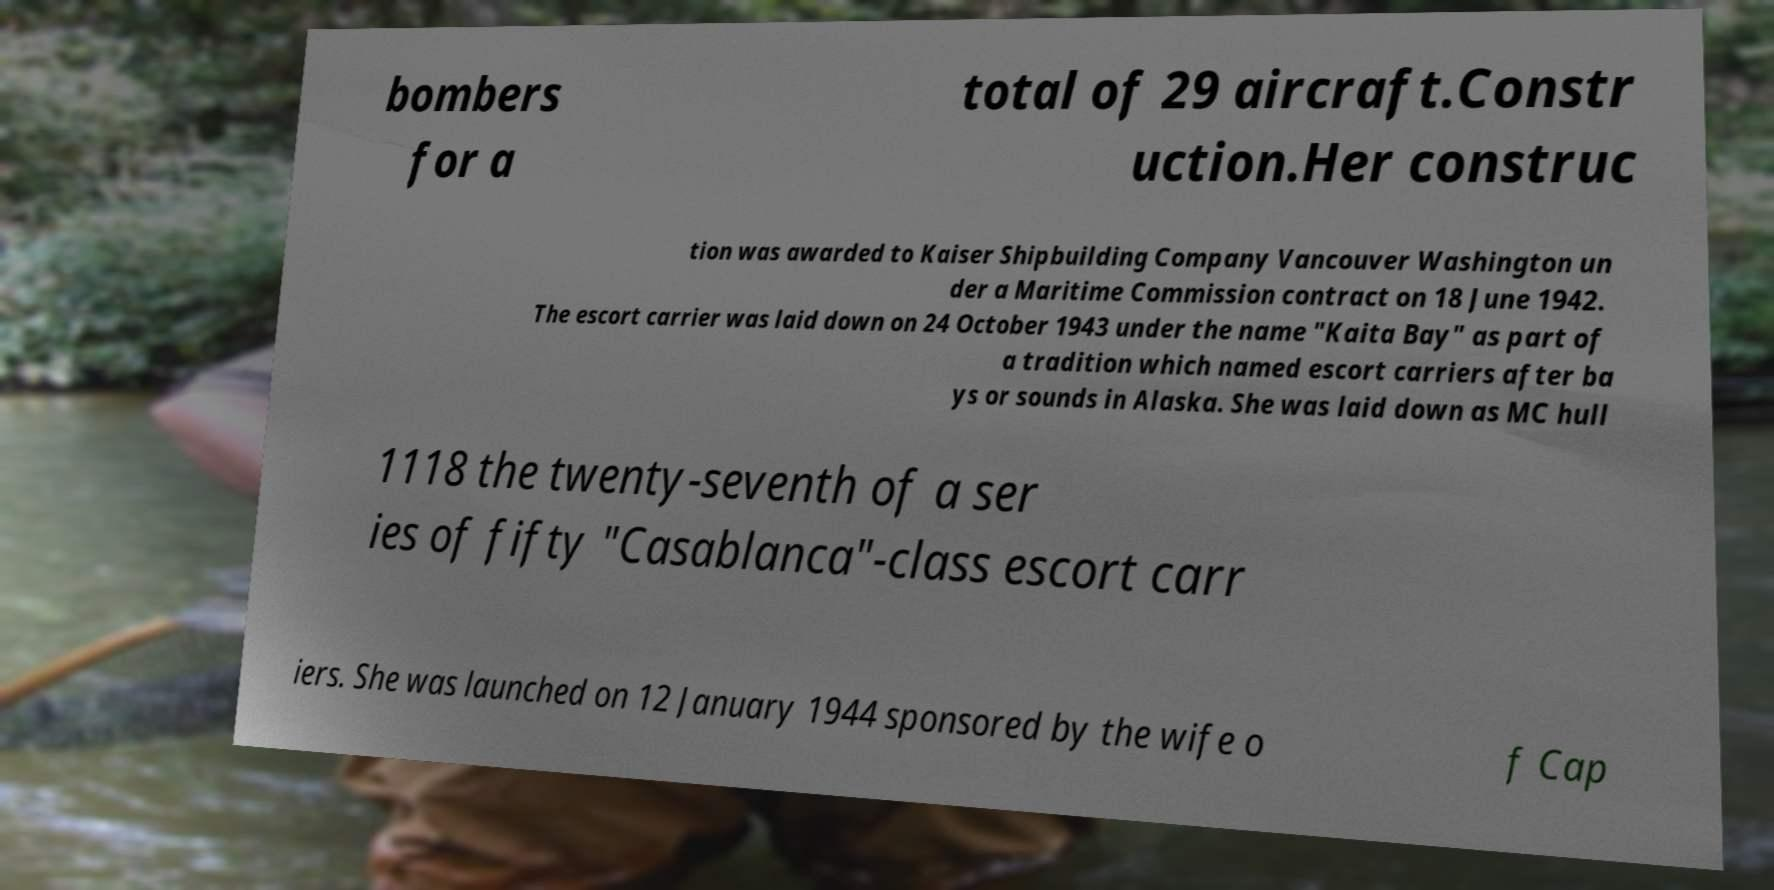I need the written content from this picture converted into text. Can you do that? bombers for a total of 29 aircraft.Constr uction.Her construc tion was awarded to Kaiser Shipbuilding Company Vancouver Washington un der a Maritime Commission contract on 18 June 1942. The escort carrier was laid down on 24 October 1943 under the name "Kaita Bay" as part of a tradition which named escort carriers after ba ys or sounds in Alaska. She was laid down as MC hull 1118 the twenty-seventh of a ser ies of fifty "Casablanca"-class escort carr iers. She was launched on 12 January 1944 sponsored by the wife o f Cap 